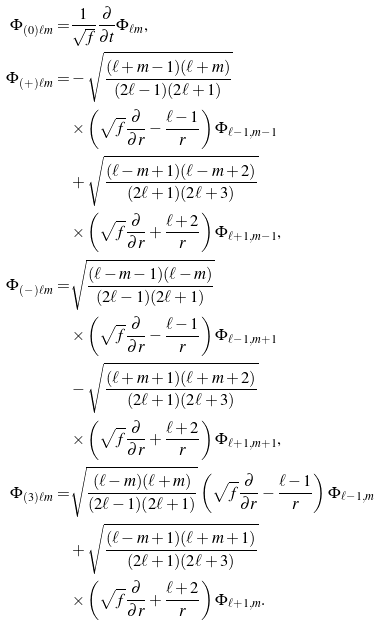Convert formula to latex. <formula><loc_0><loc_0><loc_500><loc_500>\Phi _ { ( 0 ) \ell m } = & \frac { 1 } { \sqrt { f } } \frac { \partial } { \partial t } \Phi _ { \ell m } \text {,} \\ \Phi _ { ( + ) \ell m } = & - \sqrt { \frac { ( \ell + m - 1 ) ( \ell + m ) } { ( 2 \ell - 1 ) ( 2 \ell + 1 ) } } \\ & \times \left ( \sqrt { f } \frac { \partial } { \partial r } - \frac { \ell - 1 } { r } \right ) \Phi _ { \ell - 1 , m - 1 } \\ & + \sqrt { \frac { ( \ell - m + 1 ) ( \ell - m + 2 ) } { ( 2 \ell + 1 ) ( 2 \ell + 3 ) } } \\ & \times \left ( \sqrt { f } \frac { \partial } { \partial r } + \frac { \ell + 2 } { r } \right ) \Phi _ { \ell + 1 , m - 1 } \text {,} \\ \Phi _ { ( - ) \ell m } = & \sqrt { \frac { ( \ell - m - 1 ) ( \ell - m ) } { ( 2 \ell - 1 ) ( 2 \ell + 1 ) } } \\ & \times \left ( \sqrt { f } \frac { \partial } { \partial r } - \frac { \ell - 1 } { r } \right ) \Phi _ { \ell - 1 , m + 1 } \\ & - \sqrt { \frac { ( \ell + m + 1 ) ( \ell + m + 2 ) } { ( 2 \ell + 1 ) ( 2 \ell + 3 ) } } \\ & \times \left ( \sqrt { f } \frac { \partial } { \partial r } + \frac { \ell + 2 } { r } \right ) \Phi _ { \ell + 1 , m + 1 } \text {,} \\ \Phi _ { ( 3 ) \ell m } = & \sqrt { \frac { ( \ell - m ) ( \ell + m ) } { ( 2 \ell - 1 ) ( 2 \ell + 1 ) } } \left ( \sqrt { f } \frac { \partial } { \partial r } - \frac { \ell - 1 } { r } \right ) \Phi _ { \ell - 1 , m } \\ & + \sqrt { \frac { ( \ell - m + 1 ) ( \ell + m + 1 ) } { ( 2 \ell + 1 ) ( 2 \ell + 3 ) } } \\ & \times \left ( \sqrt { f } \frac { \partial } { \partial r } + \frac { \ell + 2 } { r } \right ) \Phi _ { \ell + 1 , m } \text {.}</formula> 